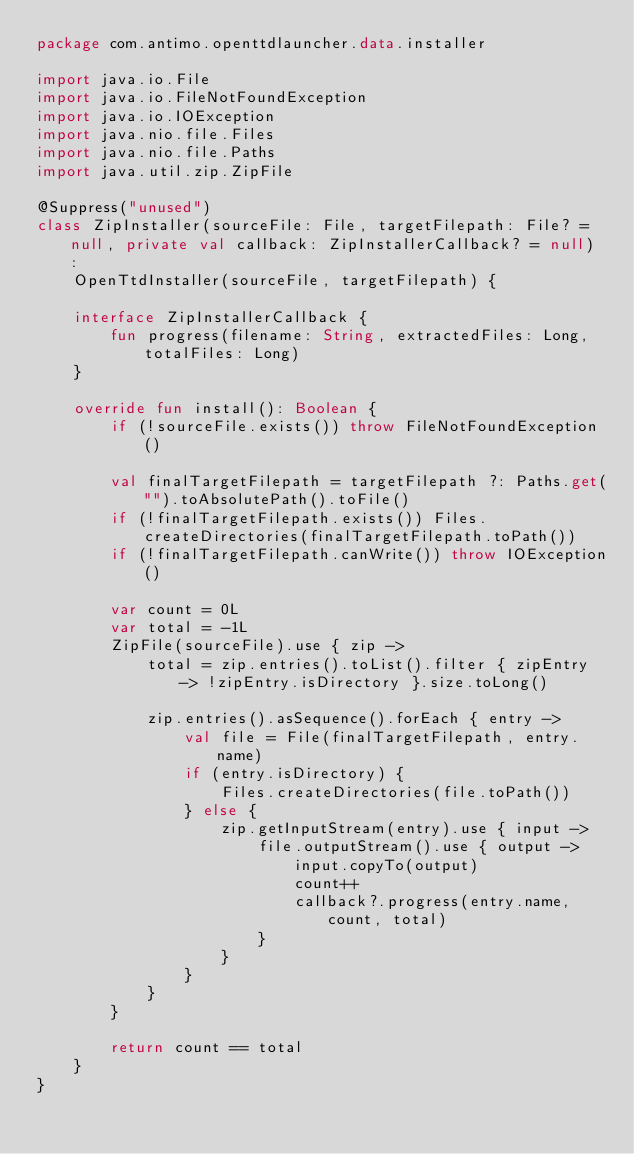<code> <loc_0><loc_0><loc_500><loc_500><_Kotlin_>package com.antimo.openttdlauncher.data.installer

import java.io.File
import java.io.FileNotFoundException
import java.io.IOException
import java.nio.file.Files
import java.nio.file.Paths
import java.util.zip.ZipFile

@Suppress("unused")
class ZipInstaller(sourceFile: File, targetFilepath: File? = null, private val callback: ZipInstallerCallback? = null) :
    OpenTtdInstaller(sourceFile, targetFilepath) {

    interface ZipInstallerCallback {
        fun progress(filename: String, extractedFiles: Long, totalFiles: Long)
    }

    override fun install(): Boolean {
        if (!sourceFile.exists()) throw FileNotFoundException()

        val finalTargetFilepath = targetFilepath ?: Paths.get("").toAbsolutePath().toFile()
        if (!finalTargetFilepath.exists()) Files.createDirectories(finalTargetFilepath.toPath())
        if (!finalTargetFilepath.canWrite()) throw IOException()

        var count = 0L
        var total = -1L
        ZipFile(sourceFile).use { zip ->
            total = zip.entries().toList().filter { zipEntry -> !zipEntry.isDirectory }.size.toLong()

            zip.entries().asSequence().forEach { entry ->
                val file = File(finalTargetFilepath, entry.name)
                if (entry.isDirectory) {
                    Files.createDirectories(file.toPath())
                } else {
                    zip.getInputStream(entry).use { input ->
                        file.outputStream().use { output ->
                            input.copyTo(output)
                            count++
                            callback?.progress(entry.name, count, total)
                        }
                    }
                }
            }
        }

        return count == total
    }
}</code> 